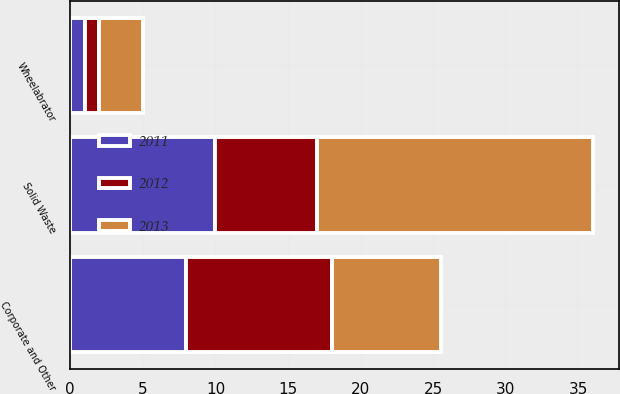Convert chart to OTSL. <chart><loc_0><loc_0><loc_500><loc_500><stacked_bar_chart><ecel><fcel>Solid Waste<fcel>Wheelabrator<fcel>Corporate and Other<nl><fcel>2012<fcel>7<fcel>1<fcel>10<nl><fcel>2013<fcel>19<fcel>3<fcel>7.5<nl><fcel>2011<fcel>10<fcel>1<fcel>8<nl></chart> 